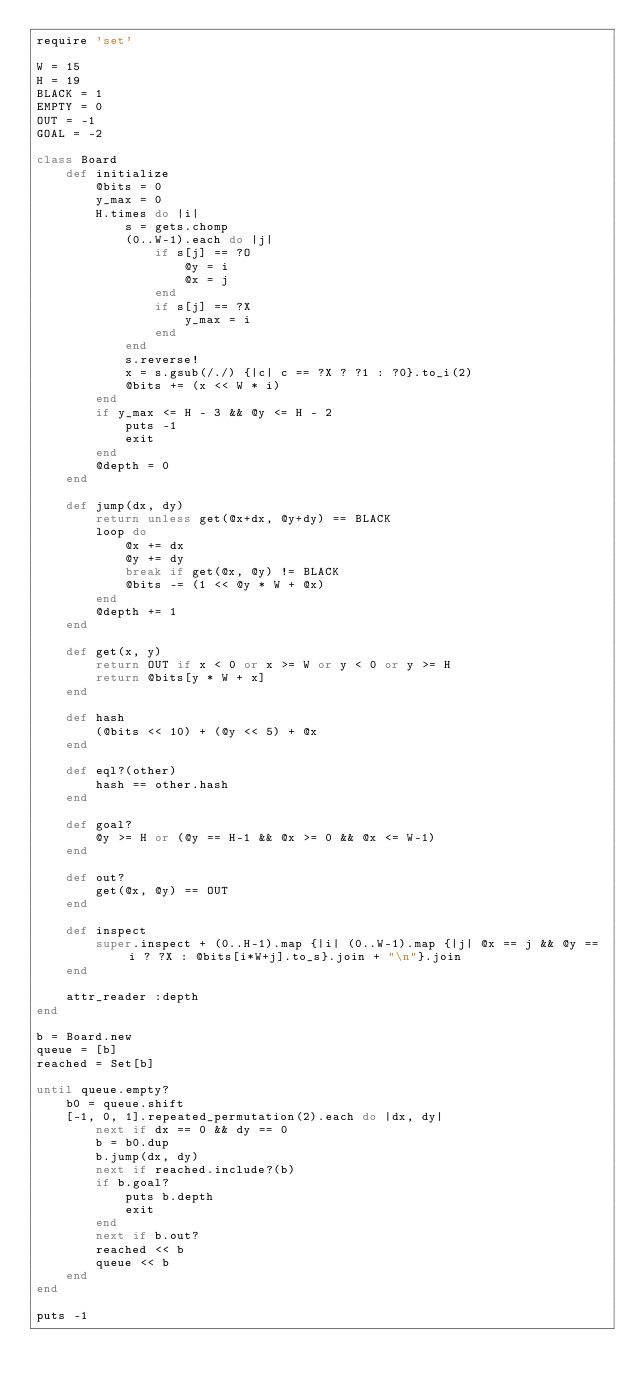Convert code to text. <code><loc_0><loc_0><loc_500><loc_500><_Ruby_>require 'set'

W = 15
H = 19
BLACK = 1
EMPTY = 0
OUT = -1
GOAL = -2

class Board
    def initialize
        @bits = 0
        y_max = 0
        H.times do |i|
            s = gets.chomp
            (0..W-1).each do |j|
                if s[j] == ?O
                    @y = i
                    @x = j
                end
                if s[j] == ?X
                    y_max = i
                end
            end
            s.reverse!
            x = s.gsub(/./) {|c| c == ?X ? ?1 : ?0}.to_i(2)
            @bits += (x << W * i)
        end
        if y_max <= H - 3 && @y <= H - 2
            puts -1
            exit
        end
        @depth = 0
    end

    def jump(dx, dy)
        return unless get(@x+dx, @y+dy) == BLACK
        loop do
            @x += dx
            @y += dy
            break if get(@x, @y) != BLACK
            @bits -= (1 << @y * W + @x)
        end
        @depth += 1
    end

    def get(x, y)
        return OUT if x < 0 or x >= W or y < 0 or y >= H
        return @bits[y * W + x]
    end

    def hash
        (@bits << 10) + (@y << 5) + @x
    end

    def eql?(other)
        hash == other.hash
    end

    def goal?
        @y >= H or (@y == H-1 && @x >= 0 && @x <= W-1)
    end

    def out?
        get(@x, @y) == OUT
    end

    def inspect
        super.inspect + (0..H-1).map {|i| (0..W-1).map {|j| @x == j && @y == i ? ?X : @bits[i*W+j].to_s}.join + "\n"}.join
    end

    attr_reader :depth
end

b = Board.new
queue = [b]
reached = Set[b]

until queue.empty?
    b0 = queue.shift
    [-1, 0, 1].repeated_permutation(2).each do |dx, dy|
        next if dx == 0 && dy == 0
        b = b0.dup
        b.jump(dx, dy)
        next if reached.include?(b)
        if b.goal?
            puts b.depth
            exit
        end
        next if b.out?
        reached << b
        queue << b
    end
end

puts -1</code> 